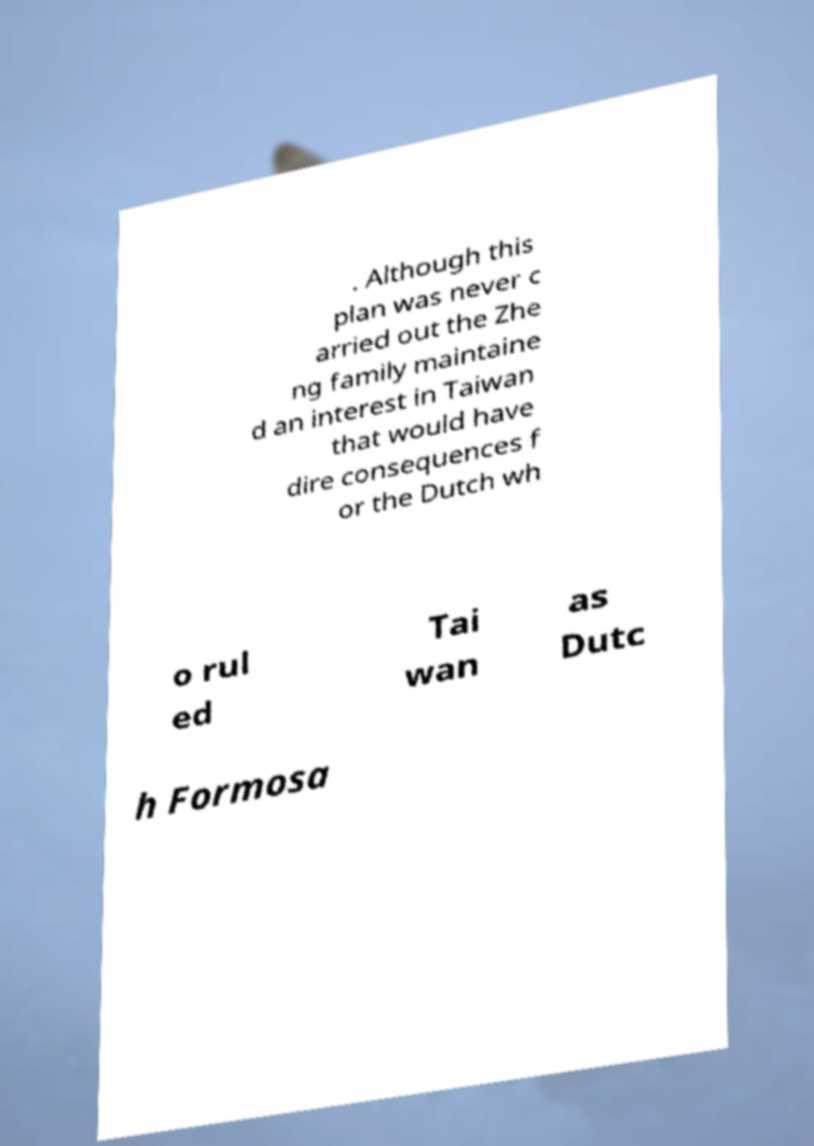What messages or text are displayed in this image? I need them in a readable, typed format. . Although this plan was never c arried out the Zhe ng family maintaine d an interest in Taiwan that would have dire consequences f or the Dutch wh o rul ed Tai wan as Dutc h Formosa 